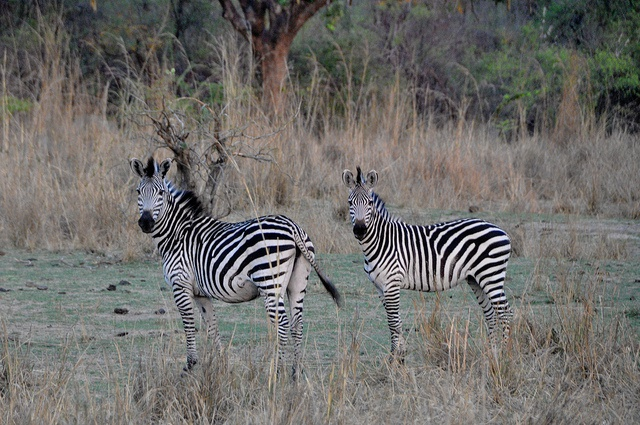Describe the objects in this image and their specific colors. I can see zebra in black, darkgray, gray, and lightgray tones and zebra in black, darkgray, gray, and lightgray tones in this image. 